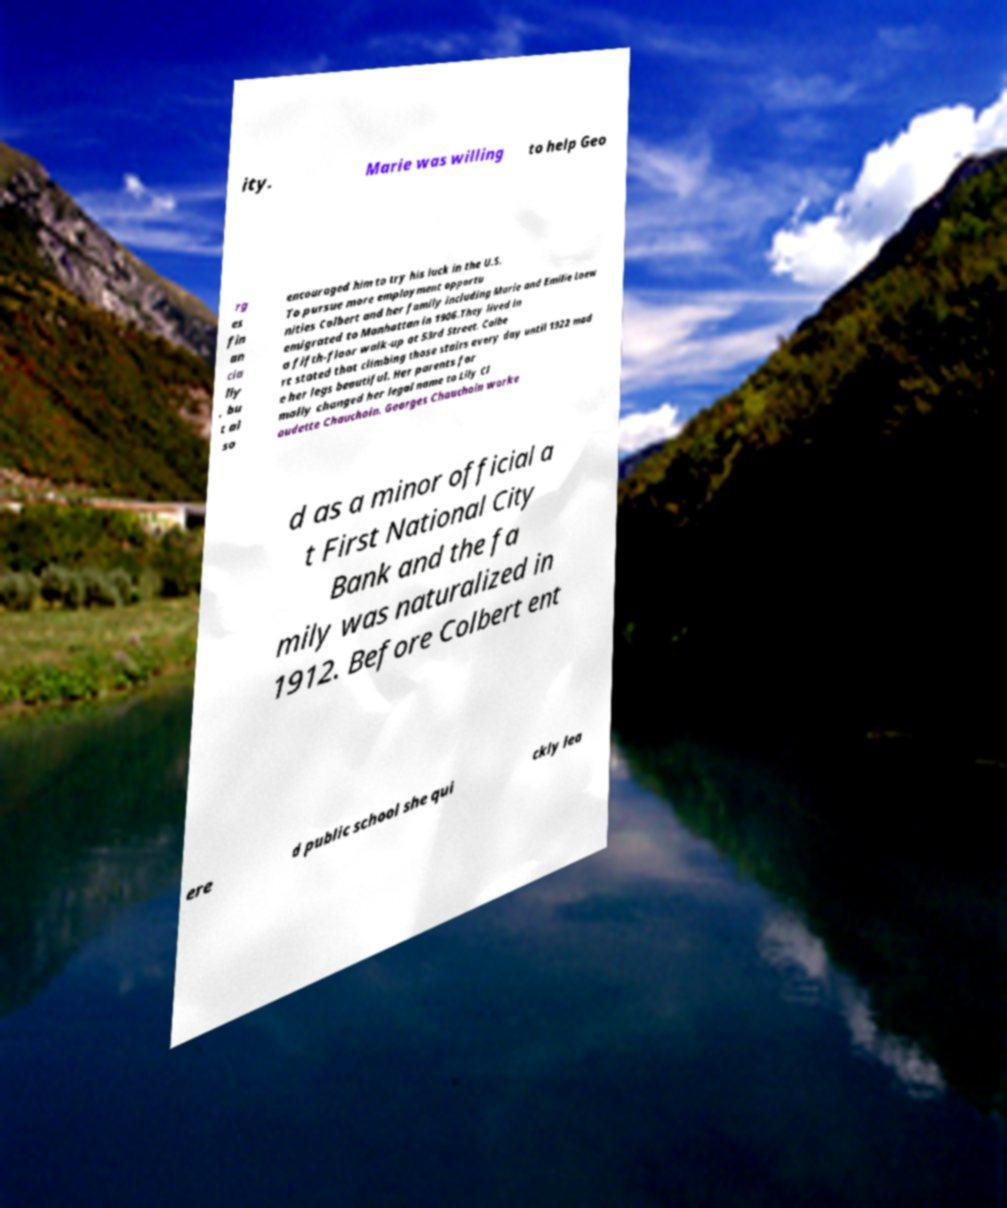I need the written content from this picture converted into text. Can you do that? ity. Marie was willing to help Geo rg es fin an cia lly , bu t al so encouraged him to try his luck in the U.S. To pursue more employment opportu nities Colbert and her family including Marie and Emilie Loew emigrated to Manhattan in 1906.They lived in a fifth-floor walk-up at 53rd Street. Colbe rt stated that climbing those stairs every day until 1922 mad e her legs beautiful. Her parents for mally changed her legal name to Lily Cl audette Chauchoin. Georges Chauchoin worke d as a minor official a t First National City Bank and the fa mily was naturalized in 1912. Before Colbert ent ere d public school she qui ckly lea 